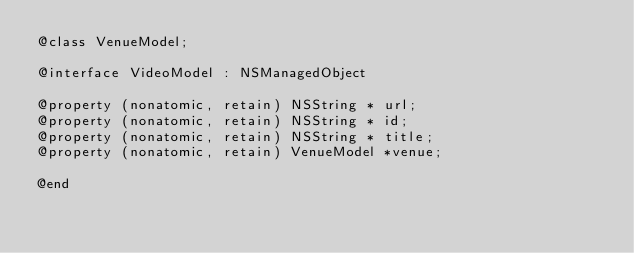Convert code to text. <code><loc_0><loc_0><loc_500><loc_500><_C_>@class VenueModel;

@interface VideoModel : NSManagedObject

@property (nonatomic, retain) NSString * url;
@property (nonatomic, retain) NSString * id;
@property (nonatomic, retain) NSString * title;
@property (nonatomic, retain) VenueModel *venue;

@end
</code> 